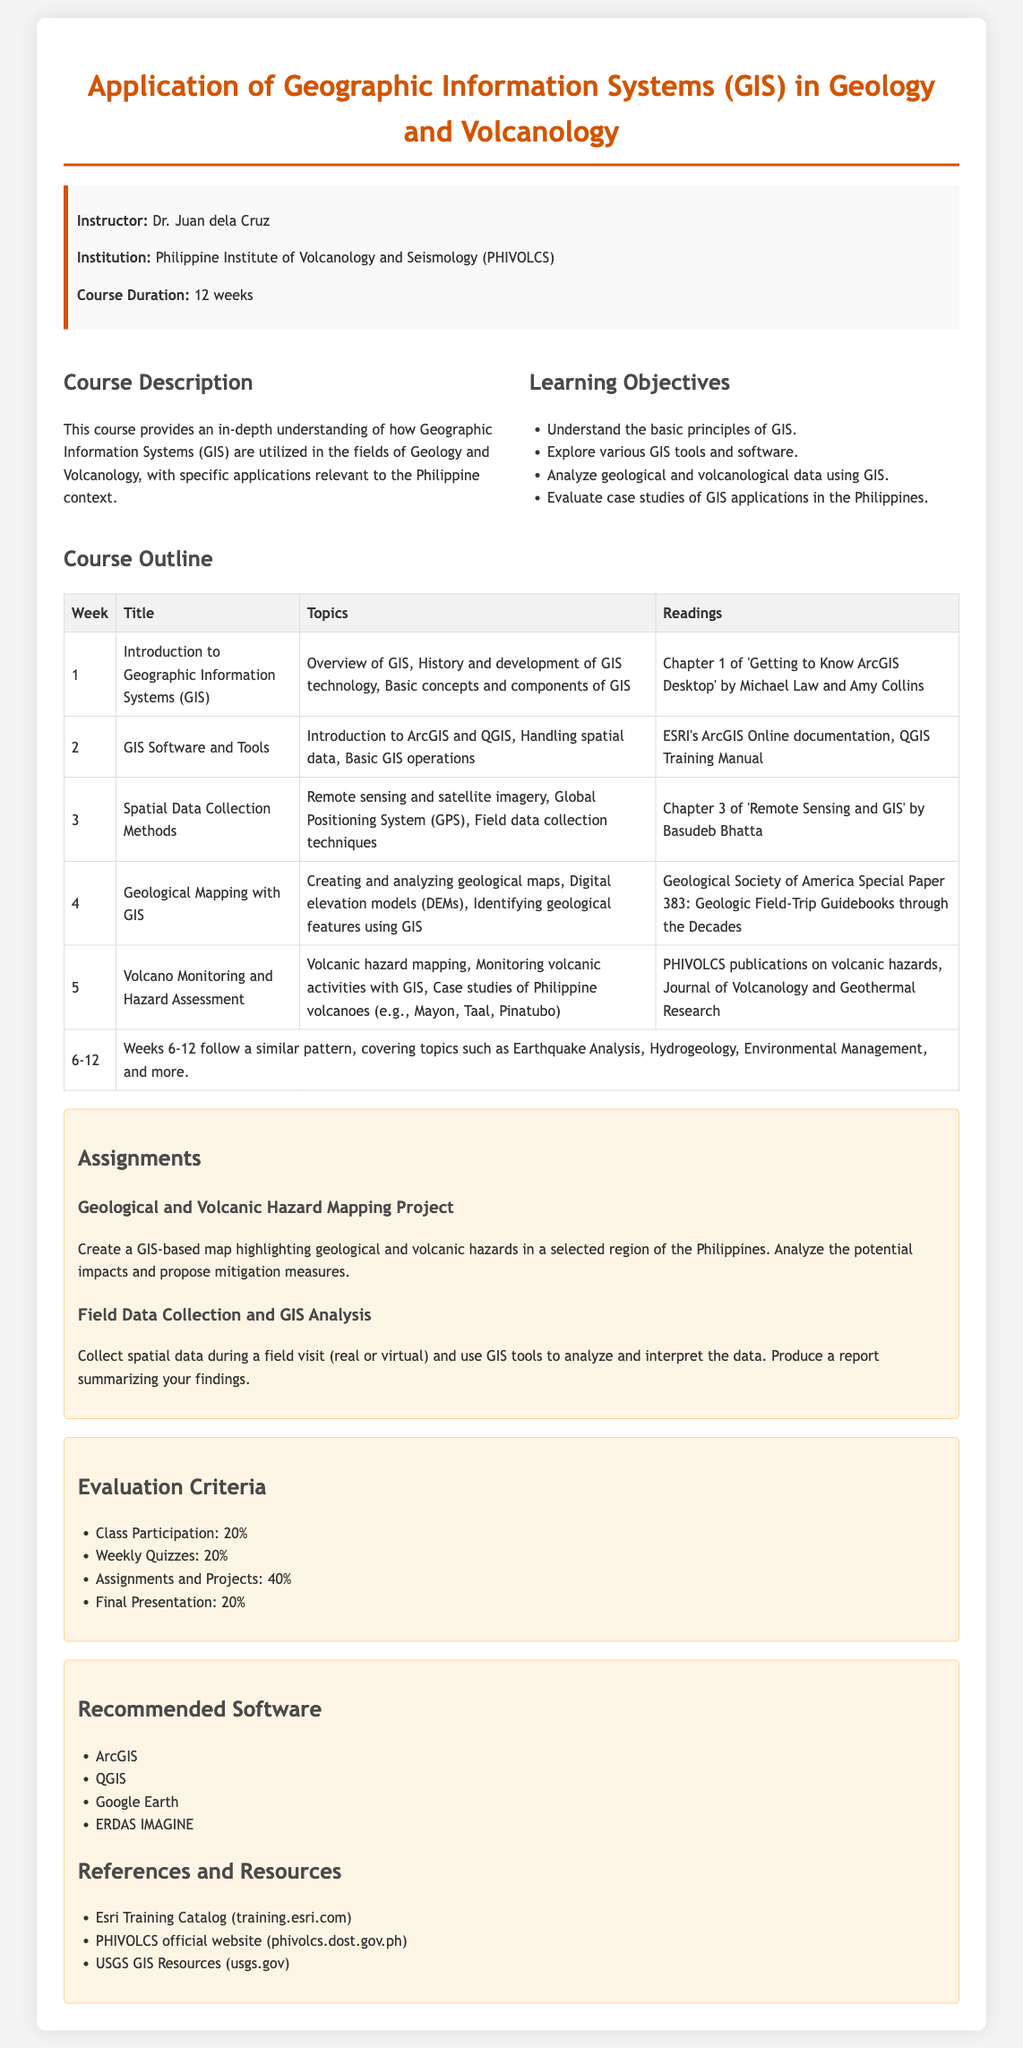What is the course title? The course title is provided in the document as the first header.
Answer: Application of Geographic Information Systems (GIS) in Geology and Volcanology Who is the instructor? The instructor's name is listed in the instructor information section of the syllabus.
Answer: Dr. Juan dela Cruz How many weeks does the course last? The course duration is specified in the instructor information section.
Answer: 12 weeks What is the first week's topic? The first week's topic is outlined in the course outline table under the title of Week 1.
Answer: Introduction to Geographic Information Systems (GIS) What percentage of the grade is class participation? The evaluation criteria section details the percentage breakdown for class participation.
Answer: 20% What software is recommended for the course? The recommended software is listed in the resources section of the syllabus.
Answer: ArcGIS What is one of the learning objectives? The learning objectives outline specific goals for the course; one can be referenced.
Answer: Understand the basic principles of GIS Which volcanoes are studied in the course? The course outline mentions specific Philippine volcanoes in Week 5's topic.
Answer: Mayon, Taal, Pinatubo What is one assignment in the syllabus? Assignments are detailed in their dedicated section with titles accompanying descriptions.
Answer: Geological and Volcanic Hazard Mapping Project 